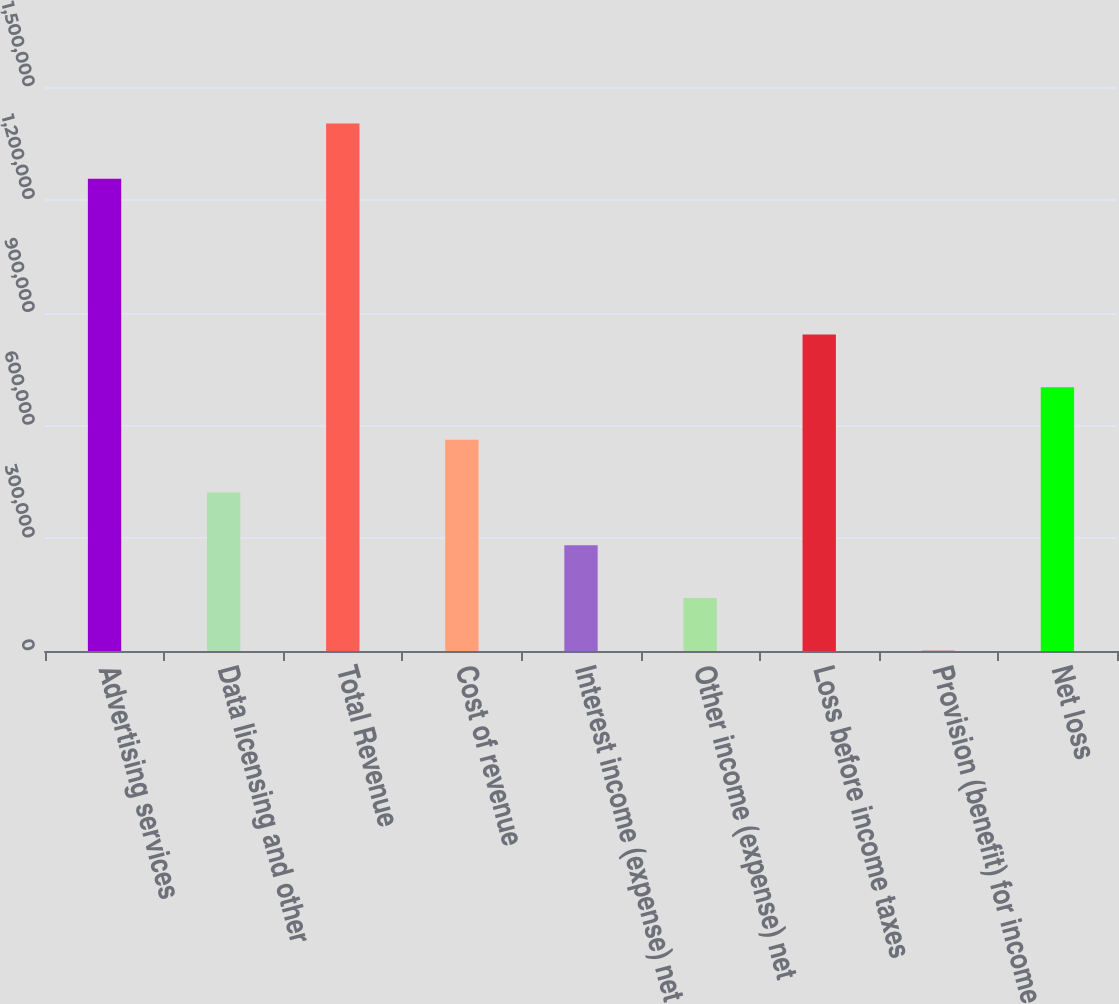<chart> <loc_0><loc_0><loc_500><loc_500><bar_chart><fcel>Advertising services<fcel>Data licensing and other<fcel>Total Revenue<fcel>Cost of revenue<fcel>Interest income (expense) net<fcel>Other income (expense) net<fcel>Loss before income taxes<fcel>Provision (benefit) for income<fcel>Net loss<nl><fcel>1.25569e+06<fcel>421272<fcel>1.403e+06<fcel>561519<fcel>281025<fcel>140778<fcel>842014<fcel>531<fcel>701766<nl></chart> 